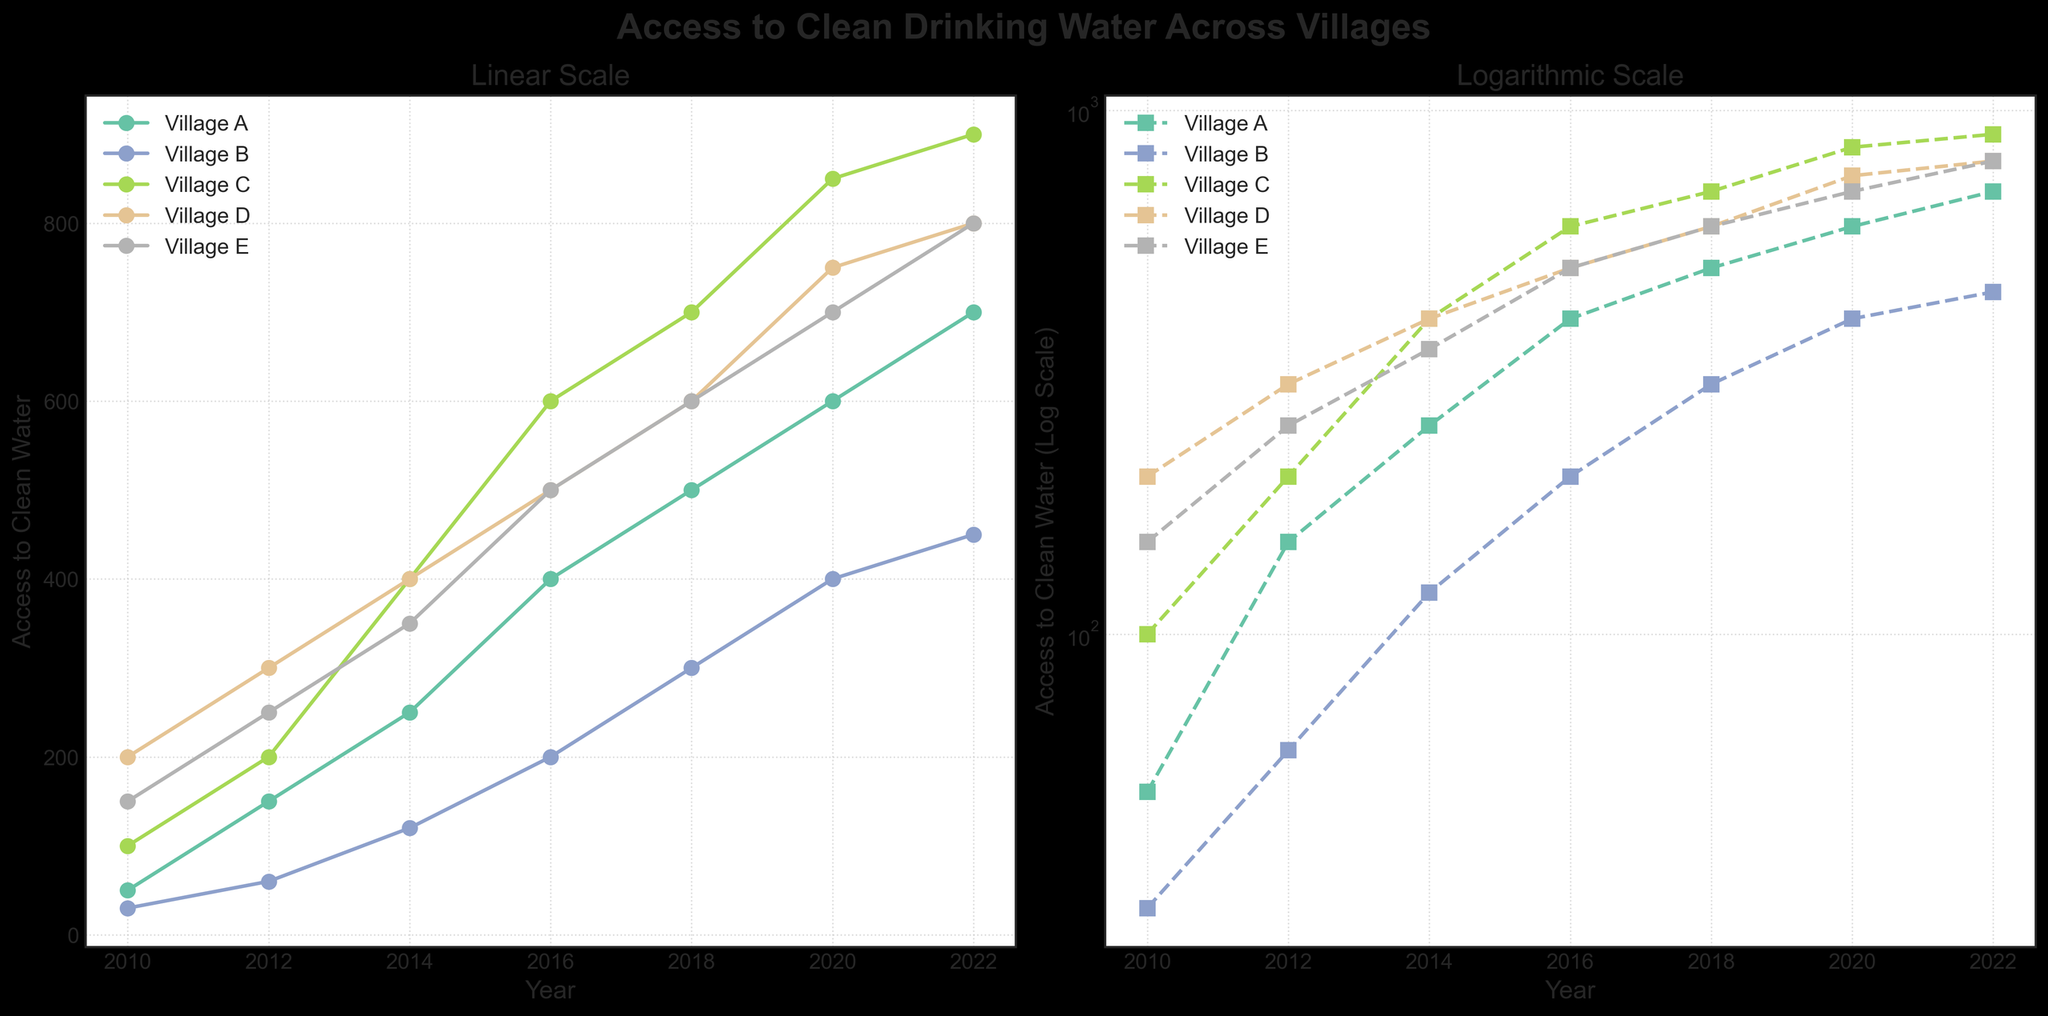What's the title of the figure? The title of the figure is given at the top center of the plot. It reads "Access to Clean Drinking Water Across Villages".
Answer: Access to Clean Drinking Water Across Villages Which village had the highest access to clean water in 2022? By looking closely at the 2022 data points on the graph, we can see that Village C reached the highest access to clean water compared to other villages in that year.
Answer: Village C How does the trend of access to clean water change over time for Village A in the linear scale subplot? In the linear scale subplot, we see that the access to clean water for Village A increases consistently over time from 2010 to 2022. The line starts at a lower value in 2010 and rises steadily upwards.
Answer: It increases consistently What is the difference in access to clean water between Village B and Village D in 2014? On the linear scale subplot, the access to clean water in 2014 for Village B is around 120, and for Village D, it is around 400. Subtracting these values gives the difference.
Answer: 280 Which year shows the greatest increase in access to clean water for Village C? By observing the slopes of the lines for Village C on the linear scale subplot, the largest increase in access to clean water occurs between 2014 and 2016, where the line shows the steepest upward trend.
Answer: Between 2014 and 2016 In the log plot, which village's access to clean water grows more steadily over the years? Examining the log scale subplot, the line for Village A maintains a relatively straight and steady upward trajectory, indicating a more consistent growth compared to other villages.
Answer: Village A Are the trends in the linear scale subplot different from those in the logarithmic scale subplot for the same village? While both subplots show the same trend direction (increase over time), the logarithmic scale subplot provides a different perspective on the growth rates. For example, rapid growths appear less steep, and consistent percentage increases are more apparent in the log subplot.
Answer: Yes Which village had the least improvement in clean water access from 2010 to 2022? Observing both subplots, Village B shows the least improvement, with a starting value around 30 in 2010 and reaching only about 450 in 2022, the smallest overall increase compared to other villages.
Answer: Village B Considering population, does a higher population imply better access to clean water among the villages? Comparing the trends and population sizes, it is not straightforward that higher population results in better access. For example, Village E had a higher population but not the highest access improvement. We can conclude that there is no direct correlation solely based on visual inspection.
Answer: No direct correlation 